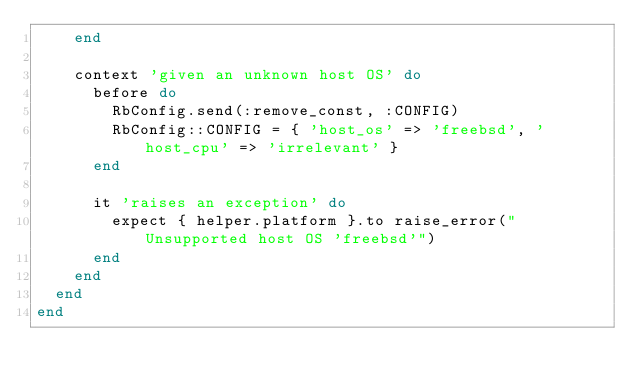Convert code to text. <code><loc_0><loc_0><loc_500><loc_500><_Ruby_>    end

    context 'given an unknown host OS' do
      before do
        RbConfig.send(:remove_const, :CONFIG)
        RbConfig::CONFIG = { 'host_os' => 'freebsd', 'host_cpu' => 'irrelevant' }
      end

      it 'raises an exception' do
        expect { helper.platform }.to raise_error("Unsupported host OS 'freebsd'")
      end
    end
  end
end
</code> 